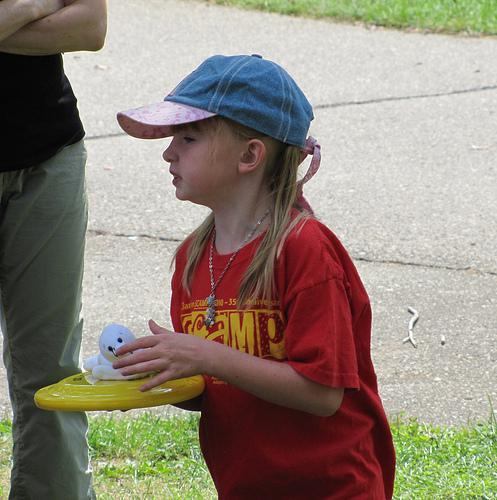Question: what is the gender of the youngster?
Choices:
A. Male.
B. Transexual.
C. Female.
D. Unknown.
Answer with the letter. Answer: C Question: how many children on the grass?
Choices:
A. One.
B. Two.
C. Six.
D. Twelve.
Answer with the letter. Answer: A Question: who is wearing a blue hat?
Choices:
A. Boy .
B. The officer.
C. Girl.
D. A friend.
Answer with the letter. Answer: C 